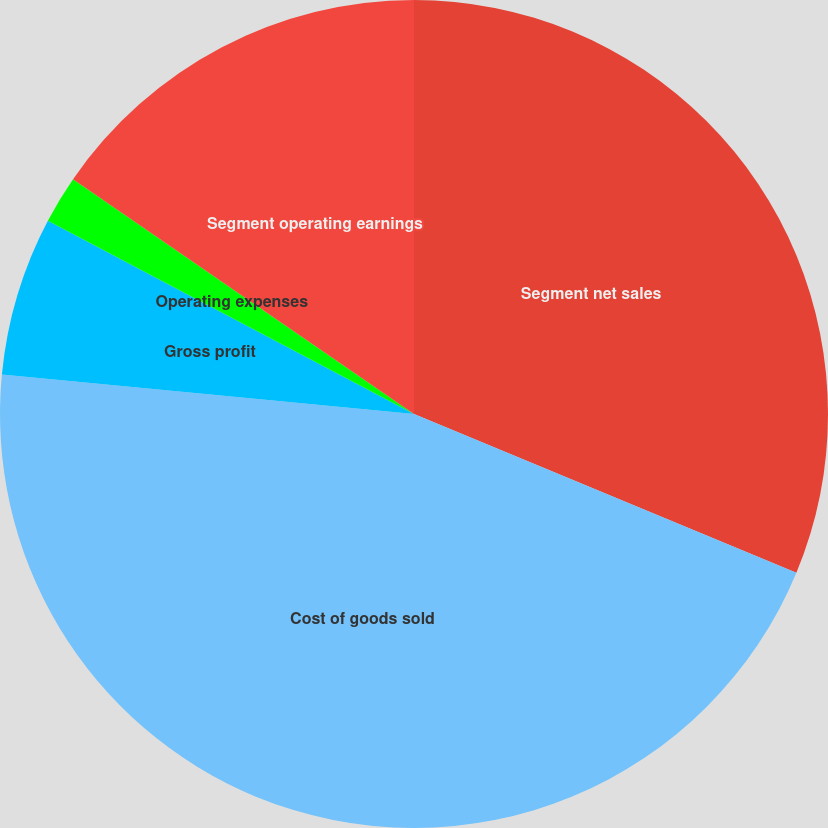Convert chart. <chart><loc_0><loc_0><loc_500><loc_500><pie_chart><fcel>Segment net sales<fcel>Cost of goods sold<fcel>Gross profit<fcel>Operating expenses<fcel>Segment operating earnings<nl><fcel>31.26%<fcel>45.26%<fcel>6.21%<fcel>1.87%<fcel>15.4%<nl></chart> 